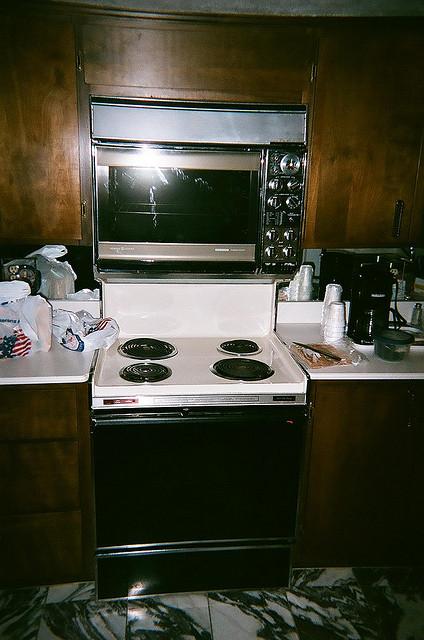What color is the coffee pot?
Keep it brief. Black. What color are the cupboards?
Write a very short answer. Brown. What room is this?
Be succinct. Kitchen. 